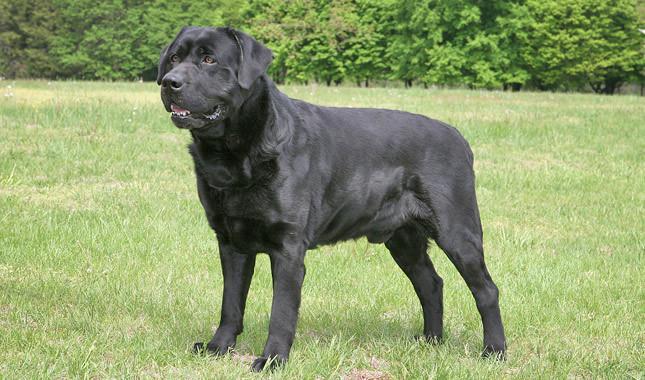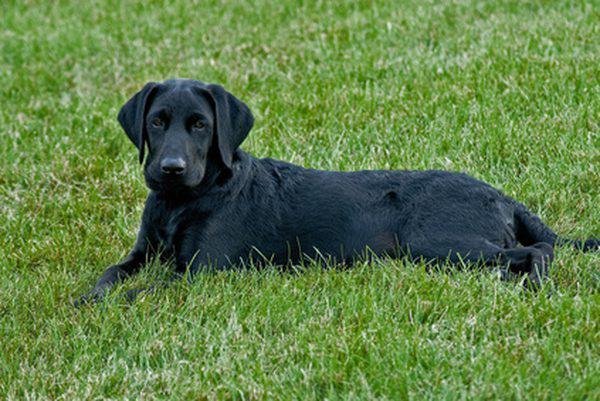The first image is the image on the left, the second image is the image on the right. Assess this claim about the two images: "In one of the images there is a single yellow lab standing on all fours on the ground outside.". Correct or not? Answer yes or no. No. 